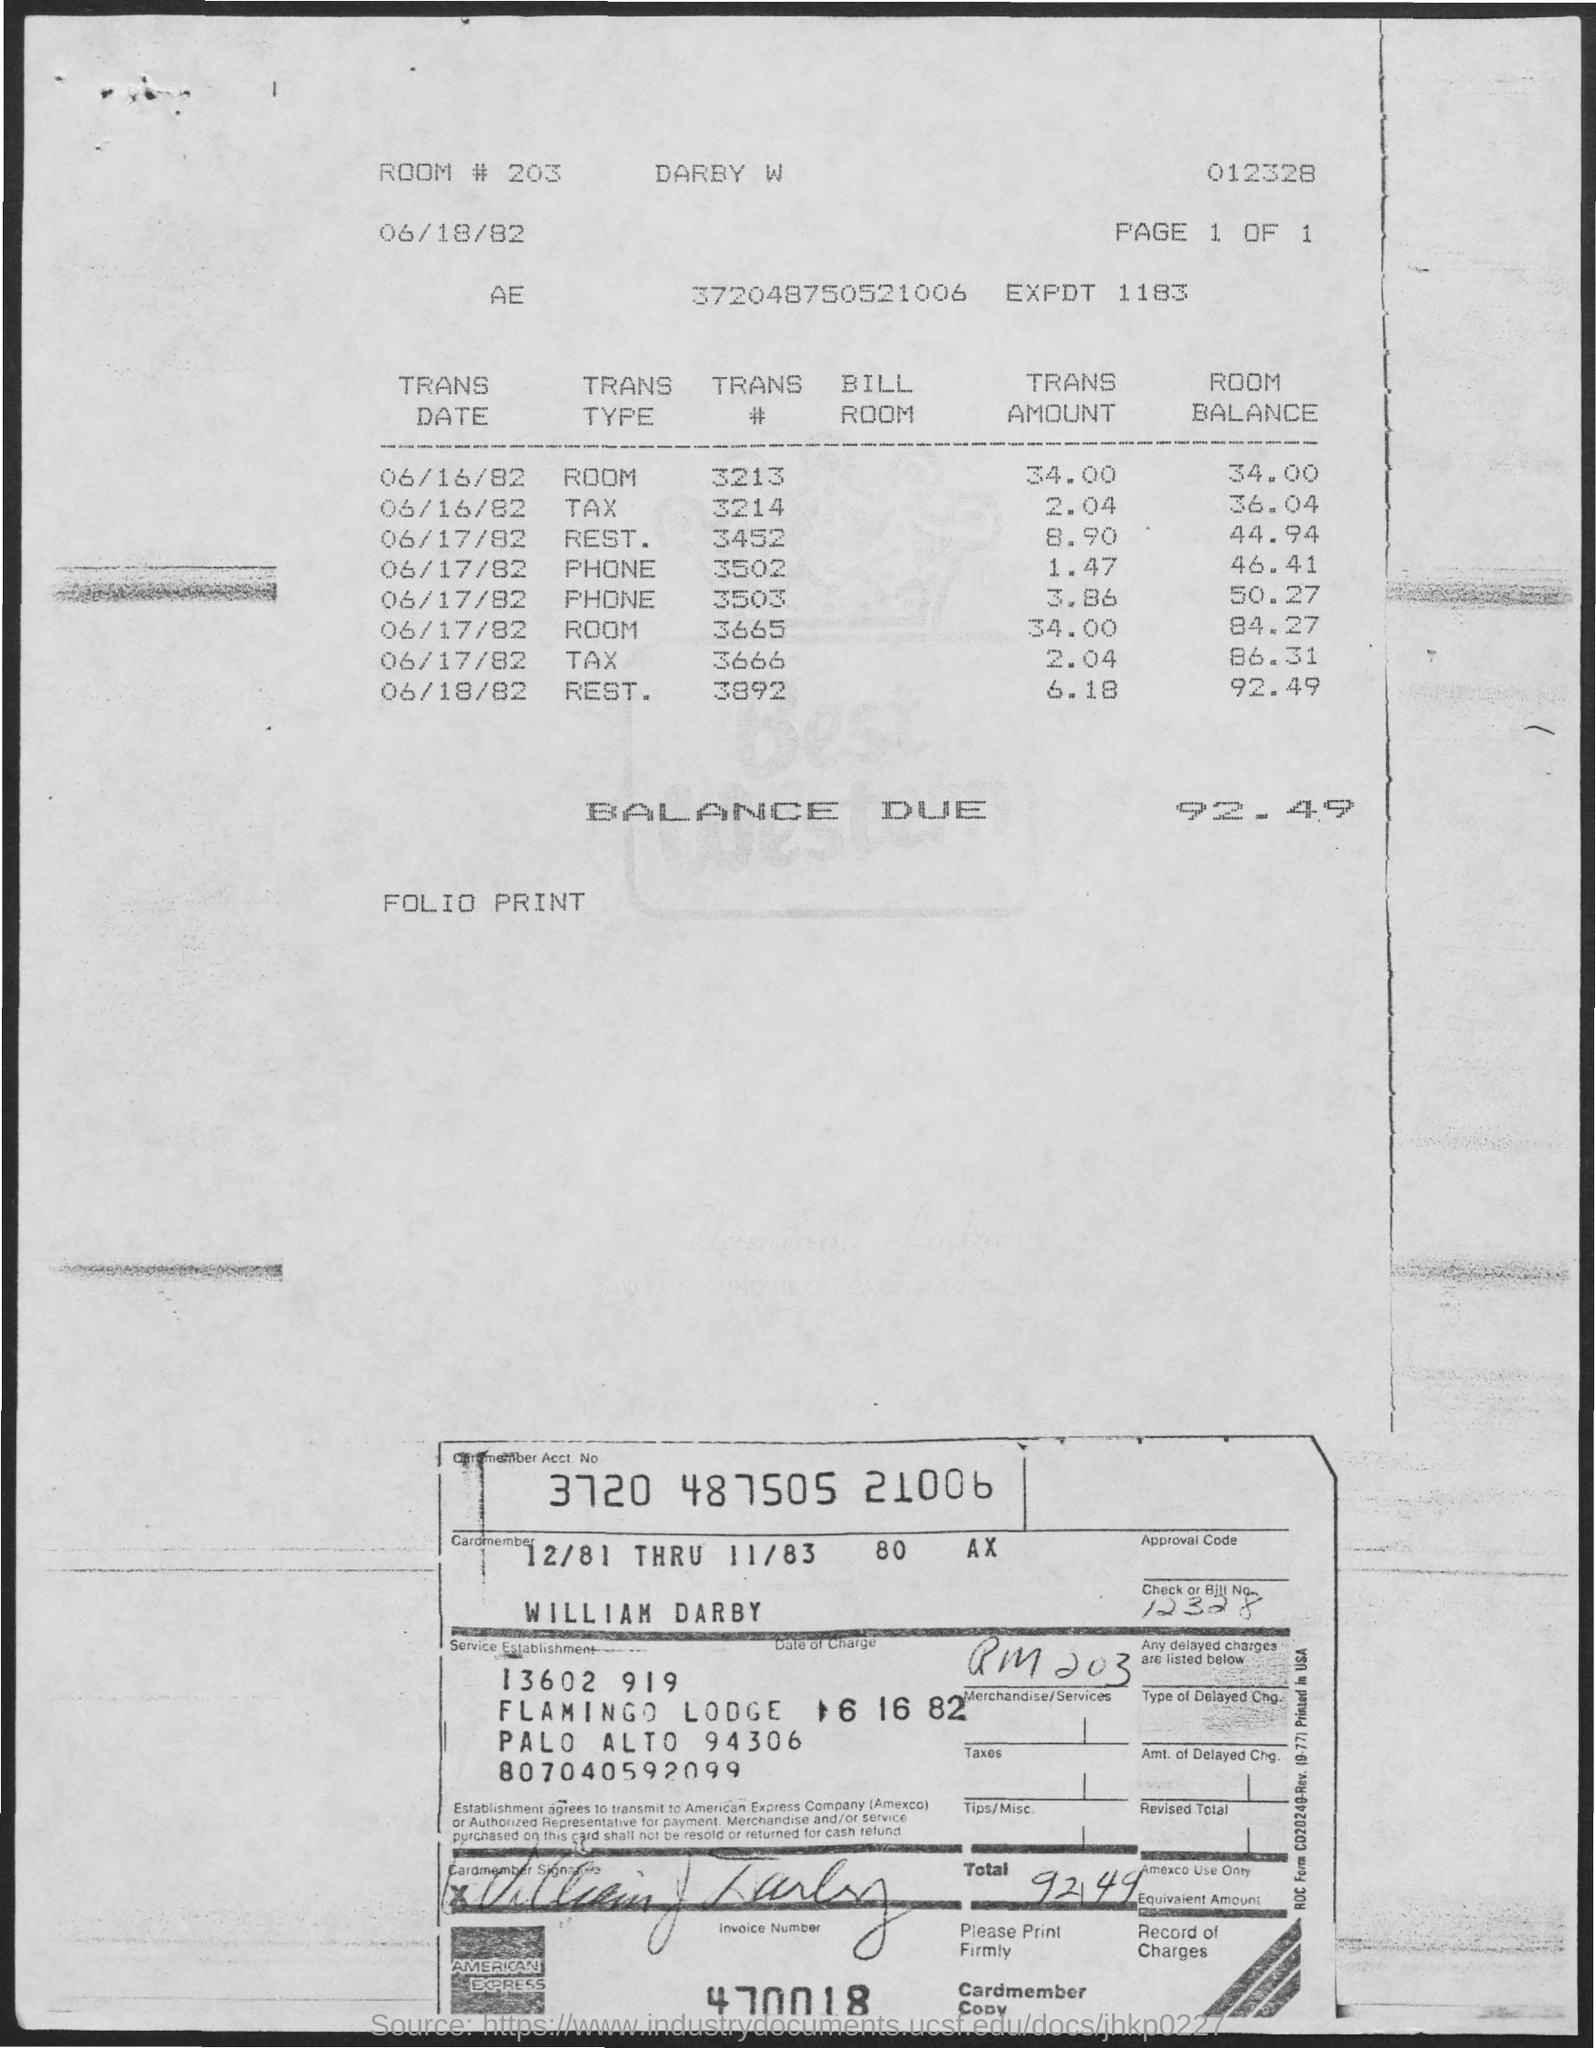What is the amount of balance due mentioned in the given page ?
Make the answer very short. 92.49. What is the room no. mentioned in the given page ?
Make the answer very short. 203. What is the transaction amount for room on 06/16/82 as mentioned in the given page ??
Give a very brief answer. 34.00. What is the transaction amount for tax on 06/16/82 ?
Provide a succinct answer. 2.04. 